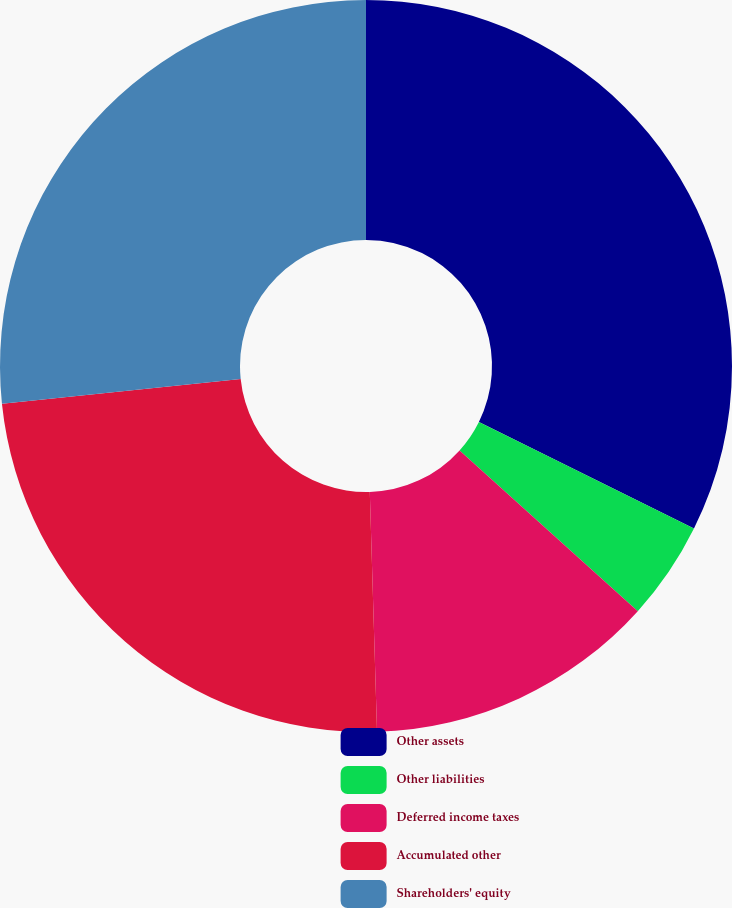Convert chart to OTSL. <chart><loc_0><loc_0><loc_500><loc_500><pie_chart><fcel>Other assets<fcel>Other liabilities<fcel>Deferred income taxes<fcel>Accumulated other<fcel>Shareholders' equity<nl><fcel>32.32%<fcel>4.36%<fcel>12.84%<fcel>23.84%<fcel>26.64%<nl></chart> 